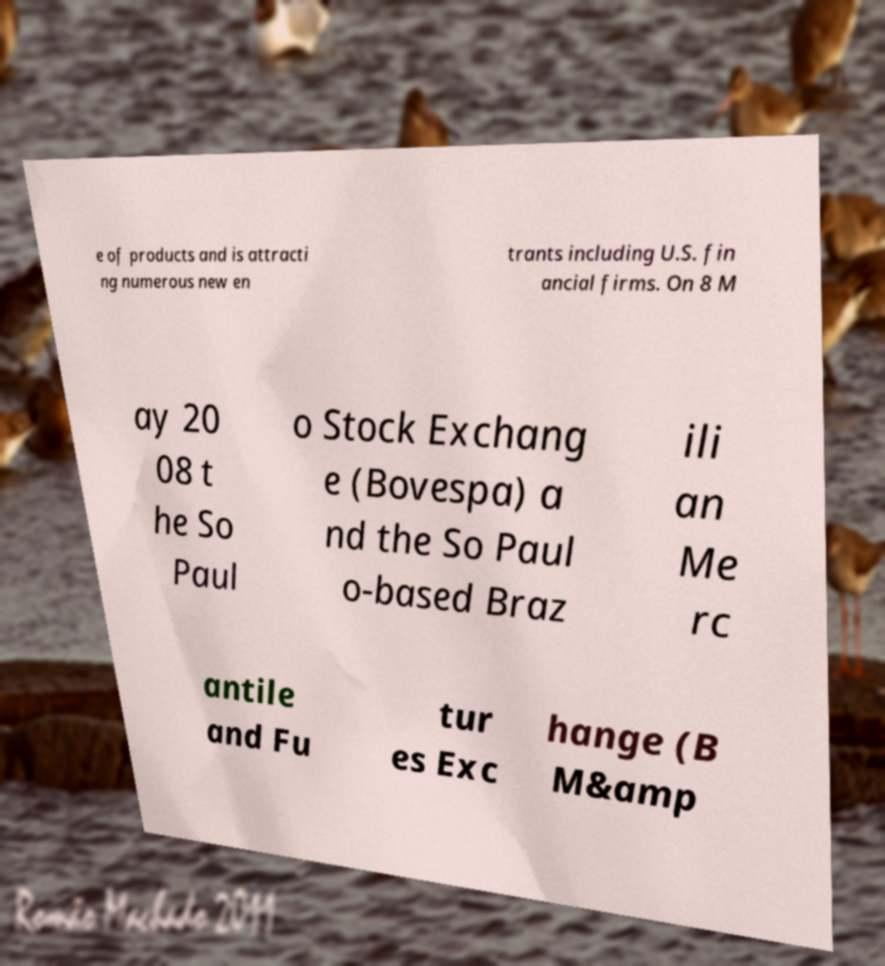What messages or text are displayed in this image? I need them in a readable, typed format. e of products and is attracti ng numerous new en trants including U.S. fin ancial firms. On 8 M ay 20 08 t he So Paul o Stock Exchang e (Bovespa) a nd the So Paul o-based Braz ili an Me rc antile and Fu tur es Exc hange (B M&amp 